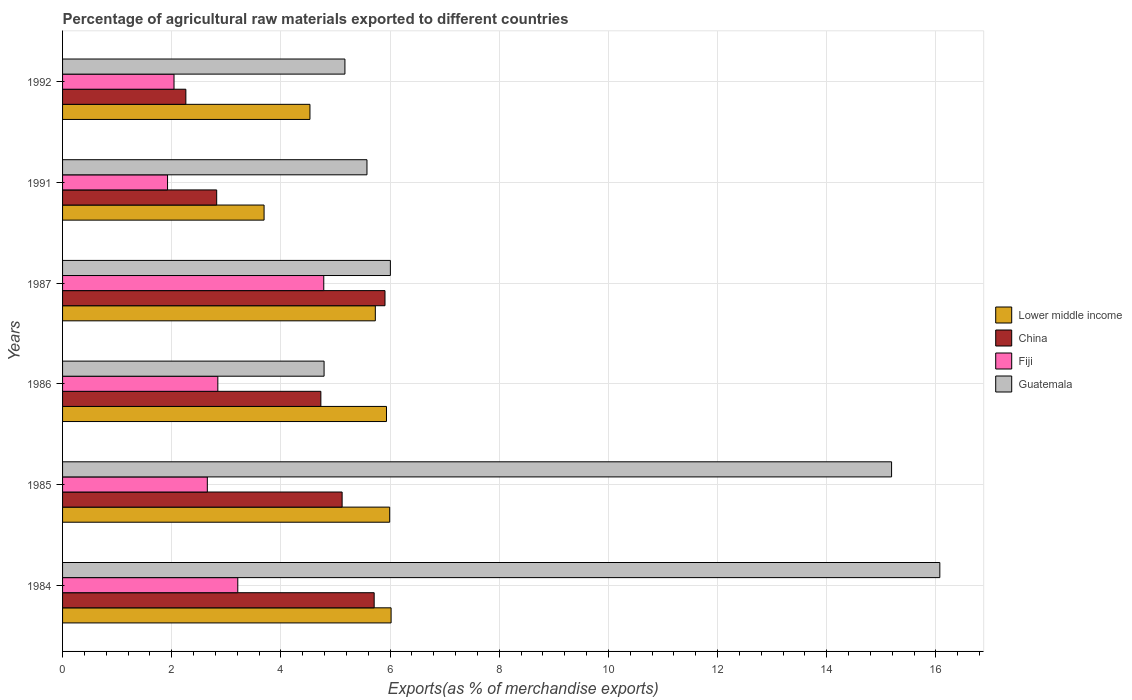How many different coloured bars are there?
Your answer should be compact. 4. Are the number of bars per tick equal to the number of legend labels?
Your response must be concise. Yes. Are the number of bars on each tick of the Y-axis equal?
Ensure brevity in your answer.  Yes. How many bars are there on the 1st tick from the top?
Offer a very short reply. 4. How many bars are there on the 3rd tick from the bottom?
Your response must be concise. 4. What is the label of the 6th group of bars from the top?
Your answer should be very brief. 1984. In how many cases, is the number of bars for a given year not equal to the number of legend labels?
Provide a short and direct response. 0. What is the percentage of exports to different countries in China in 1984?
Provide a succinct answer. 5.71. Across all years, what is the maximum percentage of exports to different countries in China?
Keep it short and to the point. 5.91. Across all years, what is the minimum percentage of exports to different countries in Lower middle income?
Offer a very short reply. 3.69. What is the total percentage of exports to different countries in Fiji in the graph?
Make the answer very short. 17.46. What is the difference between the percentage of exports to different countries in China in 1985 and that in 1992?
Your answer should be very brief. 2.86. What is the difference between the percentage of exports to different countries in Lower middle income in 1986 and the percentage of exports to different countries in Fiji in 1984?
Offer a terse response. 2.72. What is the average percentage of exports to different countries in China per year?
Your response must be concise. 4.43. In the year 1991, what is the difference between the percentage of exports to different countries in Lower middle income and percentage of exports to different countries in Fiji?
Provide a short and direct response. 1.77. What is the ratio of the percentage of exports to different countries in China in 1984 to that in 1986?
Make the answer very short. 1.21. What is the difference between the highest and the second highest percentage of exports to different countries in Guatemala?
Your response must be concise. 0.88. What is the difference between the highest and the lowest percentage of exports to different countries in Fiji?
Provide a succinct answer. 2.86. Is the sum of the percentage of exports to different countries in Fiji in 1991 and 1992 greater than the maximum percentage of exports to different countries in China across all years?
Your answer should be compact. No. Is it the case that in every year, the sum of the percentage of exports to different countries in Lower middle income and percentage of exports to different countries in China is greater than the sum of percentage of exports to different countries in Fiji and percentage of exports to different countries in Guatemala?
Make the answer very short. Yes. What does the 3rd bar from the top in 1992 represents?
Offer a very short reply. China. What does the 3rd bar from the bottom in 1987 represents?
Provide a succinct answer. Fiji. Are all the bars in the graph horizontal?
Make the answer very short. Yes. How many years are there in the graph?
Your response must be concise. 6. What is the difference between two consecutive major ticks on the X-axis?
Your answer should be very brief. 2. Are the values on the major ticks of X-axis written in scientific E-notation?
Provide a succinct answer. No. Does the graph contain grids?
Offer a very short reply. Yes. Where does the legend appear in the graph?
Ensure brevity in your answer.  Center right. What is the title of the graph?
Offer a very short reply. Percentage of agricultural raw materials exported to different countries. Does "Cyprus" appear as one of the legend labels in the graph?
Offer a terse response. No. What is the label or title of the X-axis?
Offer a very short reply. Exports(as % of merchandise exports). What is the label or title of the Y-axis?
Offer a terse response. Years. What is the Exports(as % of merchandise exports) in Lower middle income in 1984?
Your answer should be very brief. 6.02. What is the Exports(as % of merchandise exports) in China in 1984?
Ensure brevity in your answer.  5.71. What is the Exports(as % of merchandise exports) in Fiji in 1984?
Provide a short and direct response. 3.21. What is the Exports(as % of merchandise exports) of Guatemala in 1984?
Provide a short and direct response. 16.07. What is the Exports(as % of merchandise exports) of Lower middle income in 1985?
Provide a succinct answer. 5.99. What is the Exports(as % of merchandise exports) in China in 1985?
Provide a succinct answer. 5.12. What is the Exports(as % of merchandise exports) of Fiji in 1985?
Provide a short and direct response. 2.65. What is the Exports(as % of merchandise exports) in Guatemala in 1985?
Your answer should be very brief. 15.19. What is the Exports(as % of merchandise exports) of Lower middle income in 1986?
Offer a very short reply. 5.93. What is the Exports(as % of merchandise exports) in China in 1986?
Keep it short and to the point. 4.73. What is the Exports(as % of merchandise exports) of Fiji in 1986?
Offer a terse response. 2.84. What is the Exports(as % of merchandise exports) in Guatemala in 1986?
Your answer should be compact. 4.79. What is the Exports(as % of merchandise exports) of Lower middle income in 1987?
Make the answer very short. 5.73. What is the Exports(as % of merchandise exports) in China in 1987?
Your answer should be compact. 5.91. What is the Exports(as % of merchandise exports) in Fiji in 1987?
Your answer should be compact. 4.79. What is the Exports(as % of merchandise exports) in Guatemala in 1987?
Your response must be concise. 6.01. What is the Exports(as % of merchandise exports) of Lower middle income in 1991?
Ensure brevity in your answer.  3.69. What is the Exports(as % of merchandise exports) of China in 1991?
Provide a succinct answer. 2.82. What is the Exports(as % of merchandise exports) in Fiji in 1991?
Keep it short and to the point. 1.92. What is the Exports(as % of merchandise exports) of Guatemala in 1991?
Your answer should be compact. 5.58. What is the Exports(as % of merchandise exports) of Lower middle income in 1992?
Ensure brevity in your answer.  4.53. What is the Exports(as % of merchandise exports) of China in 1992?
Your response must be concise. 2.26. What is the Exports(as % of merchandise exports) in Fiji in 1992?
Make the answer very short. 2.04. What is the Exports(as % of merchandise exports) of Guatemala in 1992?
Offer a terse response. 5.17. Across all years, what is the maximum Exports(as % of merchandise exports) of Lower middle income?
Make the answer very short. 6.02. Across all years, what is the maximum Exports(as % of merchandise exports) in China?
Offer a very short reply. 5.91. Across all years, what is the maximum Exports(as % of merchandise exports) in Fiji?
Your answer should be very brief. 4.79. Across all years, what is the maximum Exports(as % of merchandise exports) in Guatemala?
Ensure brevity in your answer.  16.07. Across all years, what is the minimum Exports(as % of merchandise exports) in Lower middle income?
Provide a short and direct response. 3.69. Across all years, what is the minimum Exports(as % of merchandise exports) of China?
Provide a short and direct response. 2.26. Across all years, what is the minimum Exports(as % of merchandise exports) in Fiji?
Provide a succinct answer. 1.92. Across all years, what is the minimum Exports(as % of merchandise exports) of Guatemala?
Provide a short and direct response. 4.79. What is the total Exports(as % of merchandise exports) in Lower middle income in the graph?
Give a very brief answer. 31.9. What is the total Exports(as % of merchandise exports) of China in the graph?
Give a very brief answer. 26.55. What is the total Exports(as % of merchandise exports) of Fiji in the graph?
Give a very brief answer. 17.46. What is the total Exports(as % of merchandise exports) of Guatemala in the graph?
Offer a terse response. 52.8. What is the difference between the Exports(as % of merchandise exports) in Lower middle income in 1984 and that in 1985?
Your answer should be very brief. 0.03. What is the difference between the Exports(as % of merchandise exports) of China in 1984 and that in 1985?
Your response must be concise. 0.59. What is the difference between the Exports(as % of merchandise exports) in Fiji in 1984 and that in 1985?
Offer a terse response. 0.56. What is the difference between the Exports(as % of merchandise exports) of Guatemala in 1984 and that in 1985?
Give a very brief answer. 0.88. What is the difference between the Exports(as % of merchandise exports) in Lower middle income in 1984 and that in 1986?
Ensure brevity in your answer.  0.08. What is the difference between the Exports(as % of merchandise exports) in China in 1984 and that in 1986?
Your answer should be compact. 0.98. What is the difference between the Exports(as % of merchandise exports) of Fiji in 1984 and that in 1986?
Give a very brief answer. 0.37. What is the difference between the Exports(as % of merchandise exports) in Guatemala in 1984 and that in 1986?
Make the answer very short. 11.28. What is the difference between the Exports(as % of merchandise exports) of Lower middle income in 1984 and that in 1987?
Your answer should be compact. 0.29. What is the difference between the Exports(as % of merchandise exports) in China in 1984 and that in 1987?
Ensure brevity in your answer.  -0.2. What is the difference between the Exports(as % of merchandise exports) of Fiji in 1984 and that in 1987?
Give a very brief answer. -1.58. What is the difference between the Exports(as % of merchandise exports) in Guatemala in 1984 and that in 1987?
Offer a very short reply. 10.07. What is the difference between the Exports(as % of merchandise exports) of Lower middle income in 1984 and that in 1991?
Provide a succinct answer. 2.33. What is the difference between the Exports(as % of merchandise exports) of China in 1984 and that in 1991?
Provide a short and direct response. 2.89. What is the difference between the Exports(as % of merchandise exports) of Fiji in 1984 and that in 1991?
Your answer should be compact. 1.29. What is the difference between the Exports(as % of merchandise exports) of Guatemala in 1984 and that in 1991?
Provide a succinct answer. 10.49. What is the difference between the Exports(as % of merchandise exports) of Lower middle income in 1984 and that in 1992?
Offer a terse response. 1.49. What is the difference between the Exports(as % of merchandise exports) of China in 1984 and that in 1992?
Provide a succinct answer. 3.45. What is the difference between the Exports(as % of merchandise exports) of Fiji in 1984 and that in 1992?
Offer a terse response. 1.17. What is the difference between the Exports(as % of merchandise exports) in Guatemala in 1984 and that in 1992?
Offer a terse response. 10.9. What is the difference between the Exports(as % of merchandise exports) in Lower middle income in 1985 and that in 1986?
Make the answer very short. 0.06. What is the difference between the Exports(as % of merchandise exports) in China in 1985 and that in 1986?
Give a very brief answer. 0.39. What is the difference between the Exports(as % of merchandise exports) in Fiji in 1985 and that in 1986?
Keep it short and to the point. -0.19. What is the difference between the Exports(as % of merchandise exports) of Guatemala in 1985 and that in 1986?
Offer a very short reply. 10.4. What is the difference between the Exports(as % of merchandise exports) in Lower middle income in 1985 and that in 1987?
Ensure brevity in your answer.  0.26. What is the difference between the Exports(as % of merchandise exports) in China in 1985 and that in 1987?
Keep it short and to the point. -0.79. What is the difference between the Exports(as % of merchandise exports) of Fiji in 1985 and that in 1987?
Your answer should be very brief. -2.13. What is the difference between the Exports(as % of merchandise exports) in Guatemala in 1985 and that in 1987?
Make the answer very short. 9.18. What is the difference between the Exports(as % of merchandise exports) of Lower middle income in 1985 and that in 1991?
Provide a short and direct response. 2.3. What is the difference between the Exports(as % of merchandise exports) of China in 1985 and that in 1991?
Your response must be concise. 2.3. What is the difference between the Exports(as % of merchandise exports) of Fiji in 1985 and that in 1991?
Your response must be concise. 0.73. What is the difference between the Exports(as % of merchandise exports) of Guatemala in 1985 and that in 1991?
Your response must be concise. 9.61. What is the difference between the Exports(as % of merchandise exports) in Lower middle income in 1985 and that in 1992?
Offer a terse response. 1.46. What is the difference between the Exports(as % of merchandise exports) in China in 1985 and that in 1992?
Offer a terse response. 2.86. What is the difference between the Exports(as % of merchandise exports) in Fiji in 1985 and that in 1992?
Your response must be concise. 0.61. What is the difference between the Exports(as % of merchandise exports) in Guatemala in 1985 and that in 1992?
Give a very brief answer. 10.01. What is the difference between the Exports(as % of merchandise exports) in Lower middle income in 1986 and that in 1987?
Offer a terse response. 0.2. What is the difference between the Exports(as % of merchandise exports) in China in 1986 and that in 1987?
Your response must be concise. -1.18. What is the difference between the Exports(as % of merchandise exports) in Fiji in 1986 and that in 1987?
Provide a succinct answer. -1.94. What is the difference between the Exports(as % of merchandise exports) in Guatemala in 1986 and that in 1987?
Provide a succinct answer. -1.21. What is the difference between the Exports(as % of merchandise exports) of Lower middle income in 1986 and that in 1991?
Keep it short and to the point. 2.24. What is the difference between the Exports(as % of merchandise exports) in China in 1986 and that in 1991?
Ensure brevity in your answer.  1.91. What is the difference between the Exports(as % of merchandise exports) in Fiji in 1986 and that in 1991?
Keep it short and to the point. 0.92. What is the difference between the Exports(as % of merchandise exports) in Guatemala in 1986 and that in 1991?
Offer a very short reply. -0.79. What is the difference between the Exports(as % of merchandise exports) of Lower middle income in 1986 and that in 1992?
Your answer should be very brief. 1.4. What is the difference between the Exports(as % of merchandise exports) of China in 1986 and that in 1992?
Offer a terse response. 2.47. What is the difference between the Exports(as % of merchandise exports) in Fiji in 1986 and that in 1992?
Offer a very short reply. 0.8. What is the difference between the Exports(as % of merchandise exports) of Guatemala in 1986 and that in 1992?
Provide a succinct answer. -0.38. What is the difference between the Exports(as % of merchandise exports) of Lower middle income in 1987 and that in 1991?
Keep it short and to the point. 2.04. What is the difference between the Exports(as % of merchandise exports) in China in 1987 and that in 1991?
Offer a terse response. 3.08. What is the difference between the Exports(as % of merchandise exports) of Fiji in 1987 and that in 1991?
Your response must be concise. 2.86. What is the difference between the Exports(as % of merchandise exports) of Guatemala in 1987 and that in 1991?
Ensure brevity in your answer.  0.43. What is the difference between the Exports(as % of merchandise exports) of Lower middle income in 1987 and that in 1992?
Make the answer very short. 1.2. What is the difference between the Exports(as % of merchandise exports) in China in 1987 and that in 1992?
Make the answer very short. 3.65. What is the difference between the Exports(as % of merchandise exports) in Fiji in 1987 and that in 1992?
Your response must be concise. 2.74. What is the difference between the Exports(as % of merchandise exports) of Guatemala in 1987 and that in 1992?
Give a very brief answer. 0.83. What is the difference between the Exports(as % of merchandise exports) of Lower middle income in 1991 and that in 1992?
Keep it short and to the point. -0.84. What is the difference between the Exports(as % of merchandise exports) in China in 1991 and that in 1992?
Provide a short and direct response. 0.56. What is the difference between the Exports(as % of merchandise exports) of Fiji in 1991 and that in 1992?
Your answer should be very brief. -0.12. What is the difference between the Exports(as % of merchandise exports) in Guatemala in 1991 and that in 1992?
Keep it short and to the point. 0.4. What is the difference between the Exports(as % of merchandise exports) in Lower middle income in 1984 and the Exports(as % of merchandise exports) in China in 1985?
Provide a succinct answer. 0.9. What is the difference between the Exports(as % of merchandise exports) of Lower middle income in 1984 and the Exports(as % of merchandise exports) of Fiji in 1985?
Make the answer very short. 3.37. What is the difference between the Exports(as % of merchandise exports) of Lower middle income in 1984 and the Exports(as % of merchandise exports) of Guatemala in 1985?
Give a very brief answer. -9.17. What is the difference between the Exports(as % of merchandise exports) in China in 1984 and the Exports(as % of merchandise exports) in Fiji in 1985?
Keep it short and to the point. 3.06. What is the difference between the Exports(as % of merchandise exports) in China in 1984 and the Exports(as % of merchandise exports) in Guatemala in 1985?
Your response must be concise. -9.48. What is the difference between the Exports(as % of merchandise exports) in Fiji in 1984 and the Exports(as % of merchandise exports) in Guatemala in 1985?
Provide a short and direct response. -11.98. What is the difference between the Exports(as % of merchandise exports) of Lower middle income in 1984 and the Exports(as % of merchandise exports) of China in 1986?
Your response must be concise. 1.29. What is the difference between the Exports(as % of merchandise exports) of Lower middle income in 1984 and the Exports(as % of merchandise exports) of Fiji in 1986?
Make the answer very short. 3.17. What is the difference between the Exports(as % of merchandise exports) in Lower middle income in 1984 and the Exports(as % of merchandise exports) in Guatemala in 1986?
Provide a short and direct response. 1.23. What is the difference between the Exports(as % of merchandise exports) of China in 1984 and the Exports(as % of merchandise exports) of Fiji in 1986?
Provide a short and direct response. 2.86. What is the difference between the Exports(as % of merchandise exports) of China in 1984 and the Exports(as % of merchandise exports) of Guatemala in 1986?
Offer a terse response. 0.92. What is the difference between the Exports(as % of merchandise exports) of Fiji in 1984 and the Exports(as % of merchandise exports) of Guatemala in 1986?
Keep it short and to the point. -1.58. What is the difference between the Exports(as % of merchandise exports) of Lower middle income in 1984 and the Exports(as % of merchandise exports) of China in 1987?
Your answer should be very brief. 0.11. What is the difference between the Exports(as % of merchandise exports) in Lower middle income in 1984 and the Exports(as % of merchandise exports) in Fiji in 1987?
Offer a very short reply. 1.23. What is the difference between the Exports(as % of merchandise exports) of Lower middle income in 1984 and the Exports(as % of merchandise exports) of Guatemala in 1987?
Your answer should be compact. 0.01. What is the difference between the Exports(as % of merchandise exports) of China in 1984 and the Exports(as % of merchandise exports) of Fiji in 1987?
Your response must be concise. 0.92. What is the difference between the Exports(as % of merchandise exports) in China in 1984 and the Exports(as % of merchandise exports) in Guatemala in 1987?
Provide a short and direct response. -0.3. What is the difference between the Exports(as % of merchandise exports) of Fiji in 1984 and the Exports(as % of merchandise exports) of Guatemala in 1987?
Keep it short and to the point. -2.8. What is the difference between the Exports(as % of merchandise exports) of Lower middle income in 1984 and the Exports(as % of merchandise exports) of China in 1991?
Provide a short and direct response. 3.2. What is the difference between the Exports(as % of merchandise exports) of Lower middle income in 1984 and the Exports(as % of merchandise exports) of Fiji in 1991?
Make the answer very short. 4.1. What is the difference between the Exports(as % of merchandise exports) of Lower middle income in 1984 and the Exports(as % of merchandise exports) of Guatemala in 1991?
Make the answer very short. 0.44. What is the difference between the Exports(as % of merchandise exports) in China in 1984 and the Exports(as % of merchandise exports) in Fiji in 1991?
Give a very brief answer. 3.79. What is the difference between the Exports(as % of merchandise exports) of China in 1984 and the Exports(as % of merchandise exports) of Guatemala in 1991?
Keep it short and to the point. 0.13. What is the difference between the Exports(as % of merchandise exports) in Fiji in 1984 and the Exports(as % of merchandise exports) in Guatemala in 1991?
Provide a succinct answer. -2.37. What is the difference between the Exports(as % of merchandise exports) in Lower middle income in 1984 and the Exports(as % of merchandise exports) in China in 1992?
Your answer should be very brief. 3.76. What is the difference between the Exports(as % of merchandise exports) of Lower middle income in 1984 and the Exports(as % of merchandise exports) of Fiji in 1992?
Keep it short and to the point. 3.98. What is the difference between the Exports(as % of merchandise exports) in Lower middle income in 1984 and the Exports(as % of merchandise exports) in Guatemala in 1992?
Your answer should be compact. 0.85. What is the difference between the Exports(as % of merchandise exports) of China in 1984 and the Exports(as % of merchandise exports) of Fiji in 1992?
Your answer should be compact. 3.67. What is the difference between the Exports(as % of merchandise exports) of China in 1984 and the Exports(as % of merchandise exports) of Guatemala in 1992?
Your answer should be very brief. 0.54. What is the difference between the Exports(as % of merchandise exports) in Fiji in 1984 and the Exports(as % of merchandise exports) in Guatemala in 1992?
Ensure brevity in your answer.  -1.96. What is the difference between the Exports(as % of merchandise exports) in Lower middle income in 1985 and the Exports(as % of merchandise exports) in China in 1986?
Provide a succinct answer. 1.26. What is the difference between the Exports(as % of merchandise exports) of Lower middle income in 1985 and the Exports(as % of merchandise exports) of Fiji in 1986?
Keep it short and to the point. 3.15. What is the difference between the Exports(as % of merchandise exports) in Lower middle income in 1985 and the Exports(as % of merchandise exports) in Guatemala in 1986?
Your answer should be very brief. 1.2. What is the difference between the Exports(as % of merchandise exports) in China in 1985 and the Exports(as % of merchandise exports) in Fiji in 1986?
Keep it short and to the point. 2.28. What is the difference between the Exports(as % of merchandise exports) in China in 1985 and the Exports(as % of merchandise exports) in Guatemala in 1986?
Your response must be concise. 0.33. What is the difference between the Exports(as % of merchandise exports) of Fiji in 1985 and the Exports(as % of merchandise exports) of Guatemala in 1986?
Your response must be concise. -2.14. What is the difference between the Exports(as % of merchandise exports) in Lower middle income in 1985 and the Exports(as % of merchandise exports) in China in 1987?
Make the answer very short. 0.09. What is the difference between the Exports(as % of merchandise exports) in Lower middle income in 1985 and the Exports(as % of merchandise exports) in Fiji in 1987?
Give a very brief answer. 1.21. What is the difference between the Exports(as % of merchandise exports) of Lower middle income in 1985 and the Exports(as % of merchandise exports) of Guatemala in 1987?
Your answer should be very brief. -0.01. What is the difference between the Exports(as % of merchandise exports) in China in 1985 and the Exports(as % of merchandise exports) in Fiji in 1987?
Keep it short and to the point. 0.34. What is the difference between the Exports(as % of merchandise exports) in China in 1985 and the Exports(as % of merchandise exports) in Guatemala in 1987?
Give a very brief answer. -0.88. What is the difference between the Exports(as % of merchandise exports) in Fiji in 1985 and the Exports(as % of merchandise exports) in Guatemala in 1987?
Keep it short and to the point. -3.35. What is the difference between the Exports(as % of merchandise exports) of Lower middle income in 1985 and the Exports(as % of merchandise exports) of China in 1991?
Offer a very short reply. 3.17. What is the difference between the Exports(as % of merchandise exports) in Lower middle income in 1985 and the Exports(as % of merchandise exports) in Fiji in 1991?
Offer a very short reply. 4.07. What is the difference between the Exports(as % of merchandise exports) of Lower middle income in 1985 and the Exports(as % of merchandise exports) of Guatemala in 1991?
Offer a very short reply. 0.42. What is the difference between the Exports(as % of merchandise exports) of China in 1985 and the Exports(as % of merchandise exports) of Fiji in 1991?
Ensure brevity in your answer.  3.2. What is the difference between the Exports(as % of merchandise exports) of China in 1985 and the Exports(as % of merchandise exports) of Guatemala in 1991?
Give a very brief answer. -0.46. What is the difference between the Exports(as % of merchandise exports) of Fiji in 1985 and the Exports(as % of merchandise exports) of Guatemala in 1991?
Your answer should be very brief. -2.92. What is the difference between the Exports(as % of merchandise exports) of Lower middle income in 1985 and the Exports(as % of merchandise exports) of China in 1992?
Offer a very short reply. 3.73. What is the difference between the Exports(as % of merchandise exports) in Lower middle income in 1985 and the Exports(as % of merchandise exports) in Fiji in 1992?
Your response must be concise. 3.95. What is the difference between the Exports(as % of merchandise exports) in Lower middle income in 1985 and the Exports(as % of merchandise exports) in Guatemala in 1992?
Your response must be concise. 0.82. What is the difference between the Exports(as % of merchandise exports) of China in 1985 and the Exports(as % of merchandise exports) of Fiji in 1992?
Provide a succinct answer. 3.08. What is the difference between the Exports(as % of merchandise exports) of China in 1985 and the Exports(as % of merchandise exports) of Guatemala in 1992?
Ensure brevity in your answer.  -0.05. What is the difference between the Exports(as % of merchandise exports) of Fiji in 1985 and the Exports(as % of merchandise exports) of Guatemala in 1992?
Offer a terse response. -2.52. What is the difference between the Exports(as % of merchandise exports) of Lower middle income in 1986 and the Exports(as % of merchandise exports) of China in 1987?
Offer a very short reply. 0.03. What is the difference between the Exports(as % of merchandise exports) in Lower middle income in 1986 and the Exports(as % of merchandise exports) in Fiji in 1987?
Make the answer very short. 1.15. What is the difference between the Exports(as % of merchandise exports) in Lower middle income in 1986 and the Exports(as % of merchandise exports) in Guatemala in 1987?
Make the answer very short. -0.07. What is the difference between the Exports(as % of merchandise exports) of China in 1986 and the Exports(as % of merchandise exports) of Fiji in 1987?
Keep it short and to the point. -0.05. What is the difference between the Exports(as % of merchandise exports) of China in 1986 and the Exports(as % of merchandise exports) of Guatemala in 1987?
Your answer should be very brief. -1.27. What is the difference between the Exports(as % of merchandise exports) in Fiji in 1986 and the Exports(as % of merchandise exports) in Guatemala in 1987?
Make the answer very short. -3.16. What is the difference between the Exports(as % of merchandise exports) in Lower middle income in 1986 and the Exports(as % of merchandise exports) in China in 1991?
Your answer should be very brief. 3.11. What is the difference between the Exports(as % of merchandise exports) of Lower middle income in 1986 and the Exports(as % of merchandise exports) of Fiji in 1991?
Your response must be concise. 4.01. What is the difference between the Exports(as % of merchandise exports) of Lower middle income in 1986 and the Exports(as % of merchandise exports) of Guatemala in 1991?
Provide a short and direct response. 0.36. What is the difference between the Exports(as % of merchandise exports) of China in 1986 and the Exports(as % of merchandise exports) of Fiji in 1991?
Give a very brief answer. 2.81. What is the difference between the Exports(as % of merchandise exports) in China in 1986 and the Exports(as % of merchandise exports) in Guatemala in 1991?
Your answer should be compact. -0.84. What is the difference between the Exports(as % of merchandise exports) of Fiji in 1986 and the Exports(as % of merchandise exports) of Guatemala in 1991?
Provide a succinct answer. -2.73. What is the difference between the Exports(as % of merchandise exports) of Lower middle income in 1986 and the Exports(as % of merchandise exports) of China in 1992?
Provide a short and direct response. 3.68. What is the difference between the Exports(as % of merchandise exports) of Lower middle income in 1986 and the Exports(as % of merchandise exports) of Fiji in 1992?
Your response must be concise. 3.89. What is the difference between the Exports(as % of merchandise exports) in Lower middle income in 1986 and the Exports(as % of merchandise exports) in Guatemala in 1992?
Offer a very short reply. 0.76. What is the difference between the Exports(as % of merchandise exports) in China in 1986 and the Exports(as % of merchandise exports) in Fiji in 1992?
Give a very brief answer. 2.69. What is the difference between the Exports(as % of merchandise exports) in China in 1986 and the Exports(as % of merchandise exports) in Guatemala in 1992?
Provide a succinct answer. -0.44. What is the difference between the Exports(as % of merchandise exports) of Fiji in 1986 and the Exports(as % of merchandise exports) of Guatemala in 1992?
Your response must be concise. -2.33. What is the difference between the Exports(as % of merchandise exports) of Lower middle income in 1987 and the Exports(as % of merchandise exports) of China in 1991?
Provide a succinct answer. 2.91. What is the difference between the Exports(as % of merchandise exports) in Lower middle income in 1987 and the Exports(as % of merchandise exports) in Fiji in 1991?
Your answer should be very brief. 3.81. What is the difference between the Exports(as % of merchandise exports) in Lower middle income in 1987 and the Exports(as % of merchandise exports) in Guatemala in 1991?
Your answer should be very brief. 0.15. What is the difference between the Exports(as % of merchandise exports) of China in 1987 and the Exports(as % of merchandise exports) of Fiji in 1991?
Your answer should be compact. 3.98. What is the difference between the Exports(as % of merchandise exports) in China in 1987 and the Exports(as % of merchandise exports) in Guatemala in 1991?
Make the answer very short. 0.33. What is the difference between the Exports(as % of merchandise exports) in Fiji in 1987 and the Exports(as % of merchandise exports) in Guatemala in 1991?
Give a very brief answer. -0.79. What is the difference between the Exports(as % of merchandise exports) in Lower middle income in 1987 and the Exports(as % of merchandise exports) in China in 1992?
Offer a very short reply. 3.47. What is the difference between the Exports(as % of merchandise exports) of Lower middle income in 1987 and the Exports(as % of merchandise exports) of Fiji in 1992?
Your answer should be compact. 3.69. What is the difference between the Exports(as % of merchandise exports) of Lower middle income in 1987 and the Exports(as % of merchandise exports) of Guatemala in 1992?
Make the answer very short. 0.56. What is the difference between the Exports(as % of merchandise exports) in China in 1987 and the Exports(as % of merchandise exports) in Fiji in 1992?
Your answer should be very brief. 3.87. What is the difference between the Exports(as % of merchandise exports) of China in 1987 and the Exports(as % of merchandise exports) of Guatemala in 1992?
Your answer should be compact. 0.73. What is the difference between the Exports(as % of merchandise exports) in Fiji in 1987 and the Exports(as % of merchandise exports) in Guatemala in 1992?
Keep it short and to the point. -0.39. What is the difference between the Exports(as % of merchandise exports) of Lower middle income in 1991 and the Exports(as % of merchandise exports) of China in 1992?
Your answer should be very brief. 1.43. What is the difference between the Exports(as % of merchandise exports) in Lower middle income in 1991 and the Exports(as % of merchandise exports) in Fiji in 1992?
Provide a succinct answer. 1.65. What is the difference between the Exports(as % of merchandise exports) in Lower middle income in 1991 and the Exports(as % of merchandise exports) in Guatemala in 1992?
Give a very brief answer. -1.48. What is the difference between the Exports(as % of merchandise exports) of China in 1991 and the Exports(as % of merchandise exports) of Fiji in 1992?
Offer a very short reply. 0.78. What is the difference between the Exports(as % of merchandise exports) in China in 1991 and the Exports(as % of merchandise exports) in Guatemala in 1992?
Your response must be concise. -2.35. What is the difference between the Exports(as % of merchandise exports) of Fiji in 1991 and the Exports(as % of merchandise exports) of Guatemala in 1992?
Your answer should be very brief. -3.25. What is the average Exports(as % of merchandise exports) in Lower middle income per year?
Keep it short and to the point. 5.32. What is the average Exports(as % of merchandise exports) in China per year?
Offer a terse response. 4.43. What is the average Exports(as % of merchandise exports) of Fiji per year?
Your answer should be very brief. 2.91. What is the average Exports(as % of merchandise exports) of Guatemala per year?
Offer a very short reply. 8.8. In the year 1984, what is the difference between the Exports(as % of merchandise exports) in Lower middle income and Exports(as % of merchandise exports) in China?
Offer a very short reply. 0.31. In the year 1984, what is the difference between the Exports(as % of merchandise exports) of Lower middle income and Exports(as % of merchandise exports) of Fiji?
Your response must be concise. 2.81. In the year 1984, what is the difference between the Exports(as % of merchandise exports) in Lower middle income and Exports(as % of merchandise exports) in Guatemala?
Make the answer very short. -10.05. In the year 1984, what is the difference between the Exports(as % of merchandise exports) in China and Exports(as % of merchandise exports) in Fiji?
Make the answer very short. 2.5. In the year 1984, what is the difference between the Exports(as % of merchandise exports) of China and Exports(as % of merchandise exports) of Guatemala?
Keep it short and to the point. -10.36. In the year 1984, what is the difference between the Exports(as % of merchandise exports) in Fiji and Exports(as % of merchandise exports) in Guatemala?
Offer a terse response. -12.86. In the year 1985, what is the difference between the Exports(as % of merchandise exports) of Lower middle income and Exports(as % of merchandise exports) of China?
Offer a terse response. 0.87. In the year 1985, what is the difference between the Exports(as % of merchandise exports) of Lower middle income and Exports(as % of merchandise exports) of Fiji?
Offer a terse response. 3.34. In the year 1985, what is the difference between the Exports(as % of merchandise exports) in Lower middle income and Exports(as % of merchandise exports) in Guatemala?
Ensure brevity in your answer.  -9.19. In the year 1985, what is the difference between the Exports(as % of merchandise exports) in China and Exports(as % of merchandise exports) in Fiji?
Provide a short and direct response. 2.47. In the year 1985, what is the difference between the Exports(as % of merchandise exports) of China and Exports(as % of merchandise exports) of Guatemala?
Give a very brief answer. -10.07. In the year 1985, what is the difference between the Exports(as % of merchandise exports) in Fiji and Exports(as % of merchandise exports) in Guatemala?
Give a very brief answer. -12.54. In the year 1986, what is the difference between the Exports(as % of merchandise exports) of Lower middle income and Exports(as % of merchandise exports) of China?
Keep it short and to the point. 1.2. In the year 1986, what is the difference between the Exports(as % of merchandise exports) of Lower middle income and Exports(as % of merchandise exports) of Fiji?
Your answer should be very brief. 3.09. In the year 1986, what is the difference between the Exports(as % of merchandise exports) in Lower middle income and Exports(as % of merchandise exports) in Guatemala?
Provide a succinct answer. 1.14. In the year 1986, what is the difference between the Exports(as % of merchandise exports) of China and Exports(as % of merchandise exports) of Fiji?
Your response must be concise. 1.89. In the year 1986, what is the difference between the Exports(as % of merchandise exports) of China and Exports(as % of merchandise exports) of Guatemala?
Your answer should be very brief. -0.06. In the year 1986, what is the difference between the Exports(as % of merchandise exports) of Fiji and Exports(as % of merchandise exports) of Guatemala?
Offer a terse response. -1.95. In the year 1987, what is the difference between the Exports(as % of merchandise exports) of Lower middle income and Exports(as % of merchandise exports) of China?
Your answer should be very brief. -0.18. In the year 1987, what is the difference between the Exports(as % of merchandise exports) of Lower middle income and Exports(as % of merchandise exports) of Fiji?
Your answer should be very brief. 0.94. In the year 1987, what is the difference between the Exports(as % of merchandise exports) of Lower middle income and Exports(as % of merchandise exports) of Guatemala?
Keep it short and to the point. -0.28. In the year 1987, what is the difference between the Exports(as % of merchandise exports) of China and Exports(as % of merchandise exports) of Fiji?
Give a very brief answer. 1.12. In the year 1987, what is the difference between the Exports(as % of merchandise exports) of China and Exports(as % of merchandise exports) of Guatemala?
Provide a succinct answer. -0.1. In the year 1987, what is the difference between the Exports(as % of merchandise exports) in Fiji and Exports(as % of merchandise exports) in Guatemala?
Make the answer very short. -1.22. In the year 1991, what is the difference between the Exports(as % of merchandise exports) in Lower middle income and Exports(as % of merchandise exports) in China?
Ensure brevity in your answer.  0.87. In the year 1991, what is the difference between the Exports(as % of merchandise exports) of Lower middle income and Exports(as % of merchandise exports) of Fiji?
Provide a succinct answer. 1.77. In the year 1991, what is the difference between the Exports(as % of merchandise exports) of Lower middle income and Exports(as % of merchandise exports) of Guatemala?
Offer a very short reply. -1.89. In the year 1991, what is the difference between the Exports(as % of merchandise exports) of China and Exports(as % of merchandise exports) of Fiji?
Ensure brevity in your answer.  0.9. In the year 1991, what is the difference between the Exports(as % of merchandise exports) of China and Exports(as % of merchandise exports) of Guatemala?
Keep it short and to the point. -2.75. In the year 1991, what is the difference between the Exports(as % of merchandise exports) of Fiji and Exports(as % of merchandise exports) of Guatemala?
Offer a terse response. -3.65. In the year 1992, what is the difference between the Exports(as % of merchandise exports) in Lower middle income and Exports(as % of merchandise exports) in China?
Provide a short and direct response. 2.27. In the year 1992, what is the difference between the Exports(as % of merchandise exports) in Lower middle income and Exports(as % of merchandise exports) in Fiji?
Offer a terse response. 2.49. In the year 1992, what is the difference between the Exports(as % of merchandise exports) in Lower middle income and Exports(as % of merchandise exports) in Guatemala?
Your answer should be compact. -0.64. In the year 1992, what is the difference between the Exports(as % of merchandise exports) in China and Exports(as % of merchandise exports) in Fiji?
Your answer should be very brief. 0.22. In the year 1992, what is the difference between the Exports(as % of merchandise exports) of China and Exports(as % of merchandise exports) of Guatemala?
Provide a succinct answer. -2.91. In the year 1992, what is the difference between the Exports(as % of merchandise exports) in Fiji and Exports(as % of merchandise exports) in Guatemala?
Keep it short and to the point. -3.13. What is the ratio of the Exports(as % of merchandise exports) of Lower middle income in 1984 to that in 1985?
Your answer should be compact. 1. What is the ratio of the Exports(as % of merchandise exports) of China in 1984 to that in 1985?
Your answer should be compact. 1.11. What is the ratio of the Exports(as % of merchandise exports) in Fiji in 1984 to that in 1985?
Keep it short and to the point. 1.21. What is the ratio of the Exports(as % of merchandise exports) of Guatemala in 1984 to that in 1985?
Give a very brief answer. 1.06. What is the ratio of the Exports(as % of merchandise exports) in Lower middle income in 1984 to that in 1986?
Provide a succinct answer. 1.01. What is the ratio of the Exports(as % of merchandise exports) in China in 1984 to that in 1986?
Offer a terse response. 1.21. What is the ratio of the Exports(as % of merchandise exports) in Fiji in 1984 to that in 1986?
Keep it short and to the point. 1.13. What is the ratio of the Exports(as % of merchandise exports) of Guatemala in 1984 to that in 1986?
Offer a very short reply. 3.35. What is the ratio of the Exports(as % of merchandise exports) of Lower middle income in 1984 to that in 1987?
Offer a terse response. 1.05. What is the ratio of the Exports(as % of merchandise exports) of China in 1984 to that in 1987?
Provide a succinct answer. 0.97. What is the ratio of the Exports(as % of merchandise exports) of Fiji in 1984 to that in 1987?
Your response must be concise. 0.67. What is the ratio of the Exports(as % of merchandise exports) of Guatemala in 1984 to that in 1987?
Give a very brief answer. 2.68. What is the ratio of the Exports(as % of merchandise exports) in Lower middle income in 1984 to that in 1991?
Offer a very short reply. 1.63. What is the ratio of the Exports(as % of merchandise exports) of China in 1984 to that in 1991?
Ensure brevity in your answer.  2.02. What is the ratio of the Exports(as % of merchandise exports) in Fiji in 1984 to that in 1991?
Ensure brevity in your answer.  1.67. What is the ratio of the Exports(as % of merchandise exports) of Guatemala in 1984 to that in 1991?
Give a very brief answer. 2.88. What is the ratio of the Exports(as % of merchandise exports) in Lower middle income in 1984 to that in 1992?
Make the answer very short. 1.33. What is the ratio of the Exports(as % of merchandise exports) of China in 1984 to that in 1992?
Your answer should be compact. 2.53. What is the ratio of the Exports(as % of merchandise exports) in Fiji in 1984 to that in 1992?
Offer a very short reply. 1.57. What is the ratio of the Exports(as % of merchandise exports) of Guatemala in 1984 to that in 1992?
Make the answer very short. 3.11. What is the ratio of the Exports(as % of merchandise exports) in Lower middle income in 1985 to that in 1986?
Make the answer very short. 1.01. What is the ratio of the Exports(as % of merchandise exports) in China in 1985 to that in 1986?
Keep it short and to the point. 1.08. What is the ratio of the Exports(as % of merchandise exports) of Fiji in 1985 to that in 1986?
Your answer should be compact. 0.93. What is the ratio of the Exports(as % of merchandise exports) in Guatemala in 1985 to that in 1986?
Offer a very short reply. 3.17. What is the ratio of the Exports(as % of merchandise exports) of Lower middle income in 1985 to that in 1987?
Your answer should be compact. 1.05. What is the ratio of the Exports(as % of merchandise exports) in China in 1985 to that in 1987?
Offer a very short reply. 0.87. What is the ratio of the Exports(as % of merchandise exports) in Fiji in 1985 to that in 1987?
Ensure brevity in your answer.  0.55. What is the ratio of the Exports(as % of merchandise exports) of Guatemala in 1985 to that in 1987?
Make the answer very short. 2.53. What is the ratio of the Exports(as % of merchandise exports) of Lower middle income in 1985 to that in 1991?
Your answer should be very brief. 1.62. What is the ratio of the Exports(as % of merchandise exports) of China in 1985 to that in 1991?
Your answer should be compact. 1.81. What is the ratio of the Exports(as % of merchandise exports) in Fiji in 1985 to that in 1991?
Keep it short and to the point. 1.38. What is the ratio of the Exports(as % of merchandise exports) in Guatemala in 1985 to that in 1991?
Give a very brief answer. 2.72. What is the ratio of the Exports(as % of merchandise exports) in Lower middle income in 1985 to that in 1992?
Offer a terse response. 1.32. What is the ratio of the Exports(as % of merchandise exports) in China in 1985 to that in 1992?
Provide a short and direct response. 2.27. What is the ratio of the Exports(as % of merchandise exports) in Fiji in 1985 to that in 1992?
Provide a short and direct response. 1.3. What is the ratio of the Exports(as % of merchandise exports) of Guatemala in 1985 to that in 1992?
Your response must be concise. 2.94. What is the ratio of the Exports(as % of merchandise exports) of Lower middle income in 1986 to that in 1987?
Provide a short and direct response. 1.04. What is the ratio of the Exports(as % of merchandise exports) of China in 1986 to that in 1987?
Give a very brief answer. 0.8. What is the ratio of the Exports(as % of merchandise exports) of Fiji in 1986 to that in 1987?
Provide a short and direct response. 0.59. What is the ratio of the Exports(as % of merchandise exports) of Guatemala in 1986 to that in 1987?
Your answer should be compact. 0.8. What is the ratio of the Exports(as % of merchandise exports) of Lower middle income in 1986 to that in 1991?
Provide a short and direct response. 1.61. What is the ratio of the Exports(as % of merchandise exports) in China in 1986 to that in 1991?
Offer a very short reply. 1.68. What is the ratio of the Exports(as % of merchandise exports) of Fiji in 1986 to that in 1991?
Offer a terse response. 1.48. What is the ratio of the Exports(as % of merchandise exports) of Guatemala in 1986 to that in 1991?
Make the answer very short. 0.86. What is the ratio of the Exports(as % of merchandise exports) in Lower middle income in 1986 to that in 1992?
Keep it short and to the point. 1.31. What is the ratio of the Exports(as % of merchandise exports) in China in 1986 to that in 1992?
Keep it short and to the point. 2.09. What is the ratio of the Exports(as % of merchandise exports) in Fiji in 1986 to that in 1992?
Your response must be concise. 1.39. What is the ratio of the Exports(as % of merchandise exports) in Guatemala in 1986 to that in 1992?
Your answer should be very brief. 0.93. What is the ratio of the Exports(as % of merchandise exports) of Lower middle income in 1987 to that in 1991?
Your response must be concise. 1.55. What is the ratio of the Exports(as % of merchandise exports) in China in 1987 to that in 1991?
Offer a very short reply. 2.09. What is the ratio of the Exports(as % of merchandise exports) of Fiji in 1987 to that in 1991?
Offer a very short reply. 2.49. What is the ratio of the Exports(as % of merchandise exports) in Guatemala in 1987 to that in 1991?
Your response must be concise. 1.08. What is the ratio of the Exports(as % of merchandise exports) in Lower middle income in 1987 to that in 1992?
Your answer should be very brief. 1.26. What is the ratio of the Exports(as % of merchandise exports) in China in 1987 to that in 1992?
Your answer should be compact. 2.62. What is the ratio of the Exports(as % of merchandise exports) of Fiji in 1987 to that in 1992?
Offer a terse response. 2.34. What is the ratio of the Exports(as % of merchandise exports) of Guatemala in 1987 to that in 1992?
Give a very brief answer. 1.16. What is the ratio of the Exports(as % of merchandise exports) of Lower middle income in 1991 to that in 1992?
Your answer should be compact. 0.81. What is the ratio of the Exports(as % of merchandise exports) in China in 1991 to that in 1992?
Ensure brevity in your answer.  1.25. What is the ratio of the Exports(as % of merchandise exports) in Fiji in 1991 to that in 1992?
Provide a succinct answer. 0.94. What is the ratio of the Exports(as % of merchandise exports) in Guatemala in 1991 to that in 1992?
Your answer should be very brief. 1.08. What is the difference between the highest and the second highest Exports(as % of merchandise exports) of Lower middle income?
Provide a short and direct response. 0.03. What is the difference between the highest and the second highest Exports(as % of merchandise exports) in China?
Offer a very short reply. 0.2. What is the difference between the highest and the second highest Exports(as % of merchandise exports) of Fiji?
Give a very brief answer. 1.58. What is the difference between the highest and the second highest Exports(as % of merchandise exports) of Guatemala?
Provide a succinct answer. 0.88. What is the difference between the highest and the lowest Exports(as % of merchandise exports) of Lower middle income?
Provide a succinct answer. 2.33. What is the difference between the highest and the lowest Exports(as % of merchandise exports) of China?
Your response must be concise. 3.65. What is the difference between the highest and the lowest Exports(as % of merchandise exports) of Fiji?
Offer a terse response. 2.86. What is the difference between the highest and the lowest Exports(as % of merchandise exports) of Guatemala?
Your response must be concise. 11.28. 